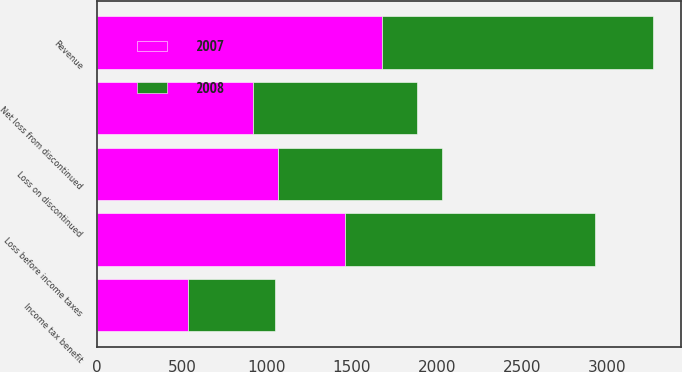Convert chart. <chart><loc_0><loc_0><loc_500><loc_500><stacked_bar_chart><ecel><fcel>Revenue<fcel>Loss before income taxes<fcel>Income tax benefit<fcel>Net loss from discontinued<fcel>Loss on discontinued<nl><fcel>2007<fcel>1680<fcel>1457<fcel>536<fcel>921<fcel>1065<nl><fcel>2008<fcel>1595<fcel>1474<fcel>511<fcel>963<fcel>963<nl></chart> 